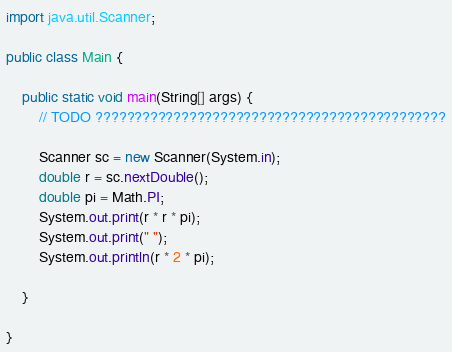<code> <loc_0><loc_0><loc_500><loc_500><_Java_>import java.util.Scanner;

public class Main {

	public static void main(String[] args) {
		// TODO ?????????????????????????????????????????????

		Scanner sc = new Scanner(System.in);
		double r = sc.nextDouble();
		double pi = Math.PI;
		System.out.print(r * r * pi);
		System.out.print(" ");
		System.out.println(r * 2 * pi);

	}

}</code> 